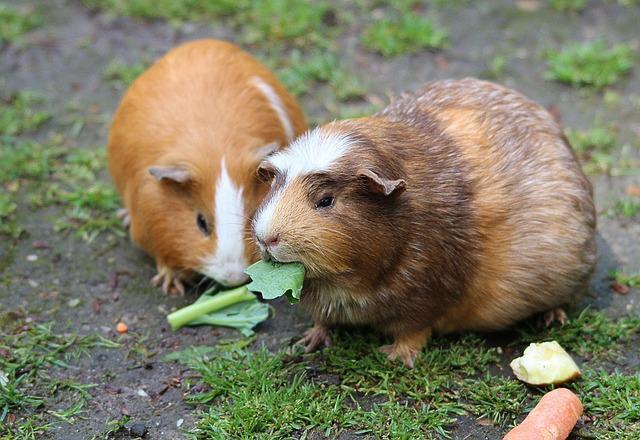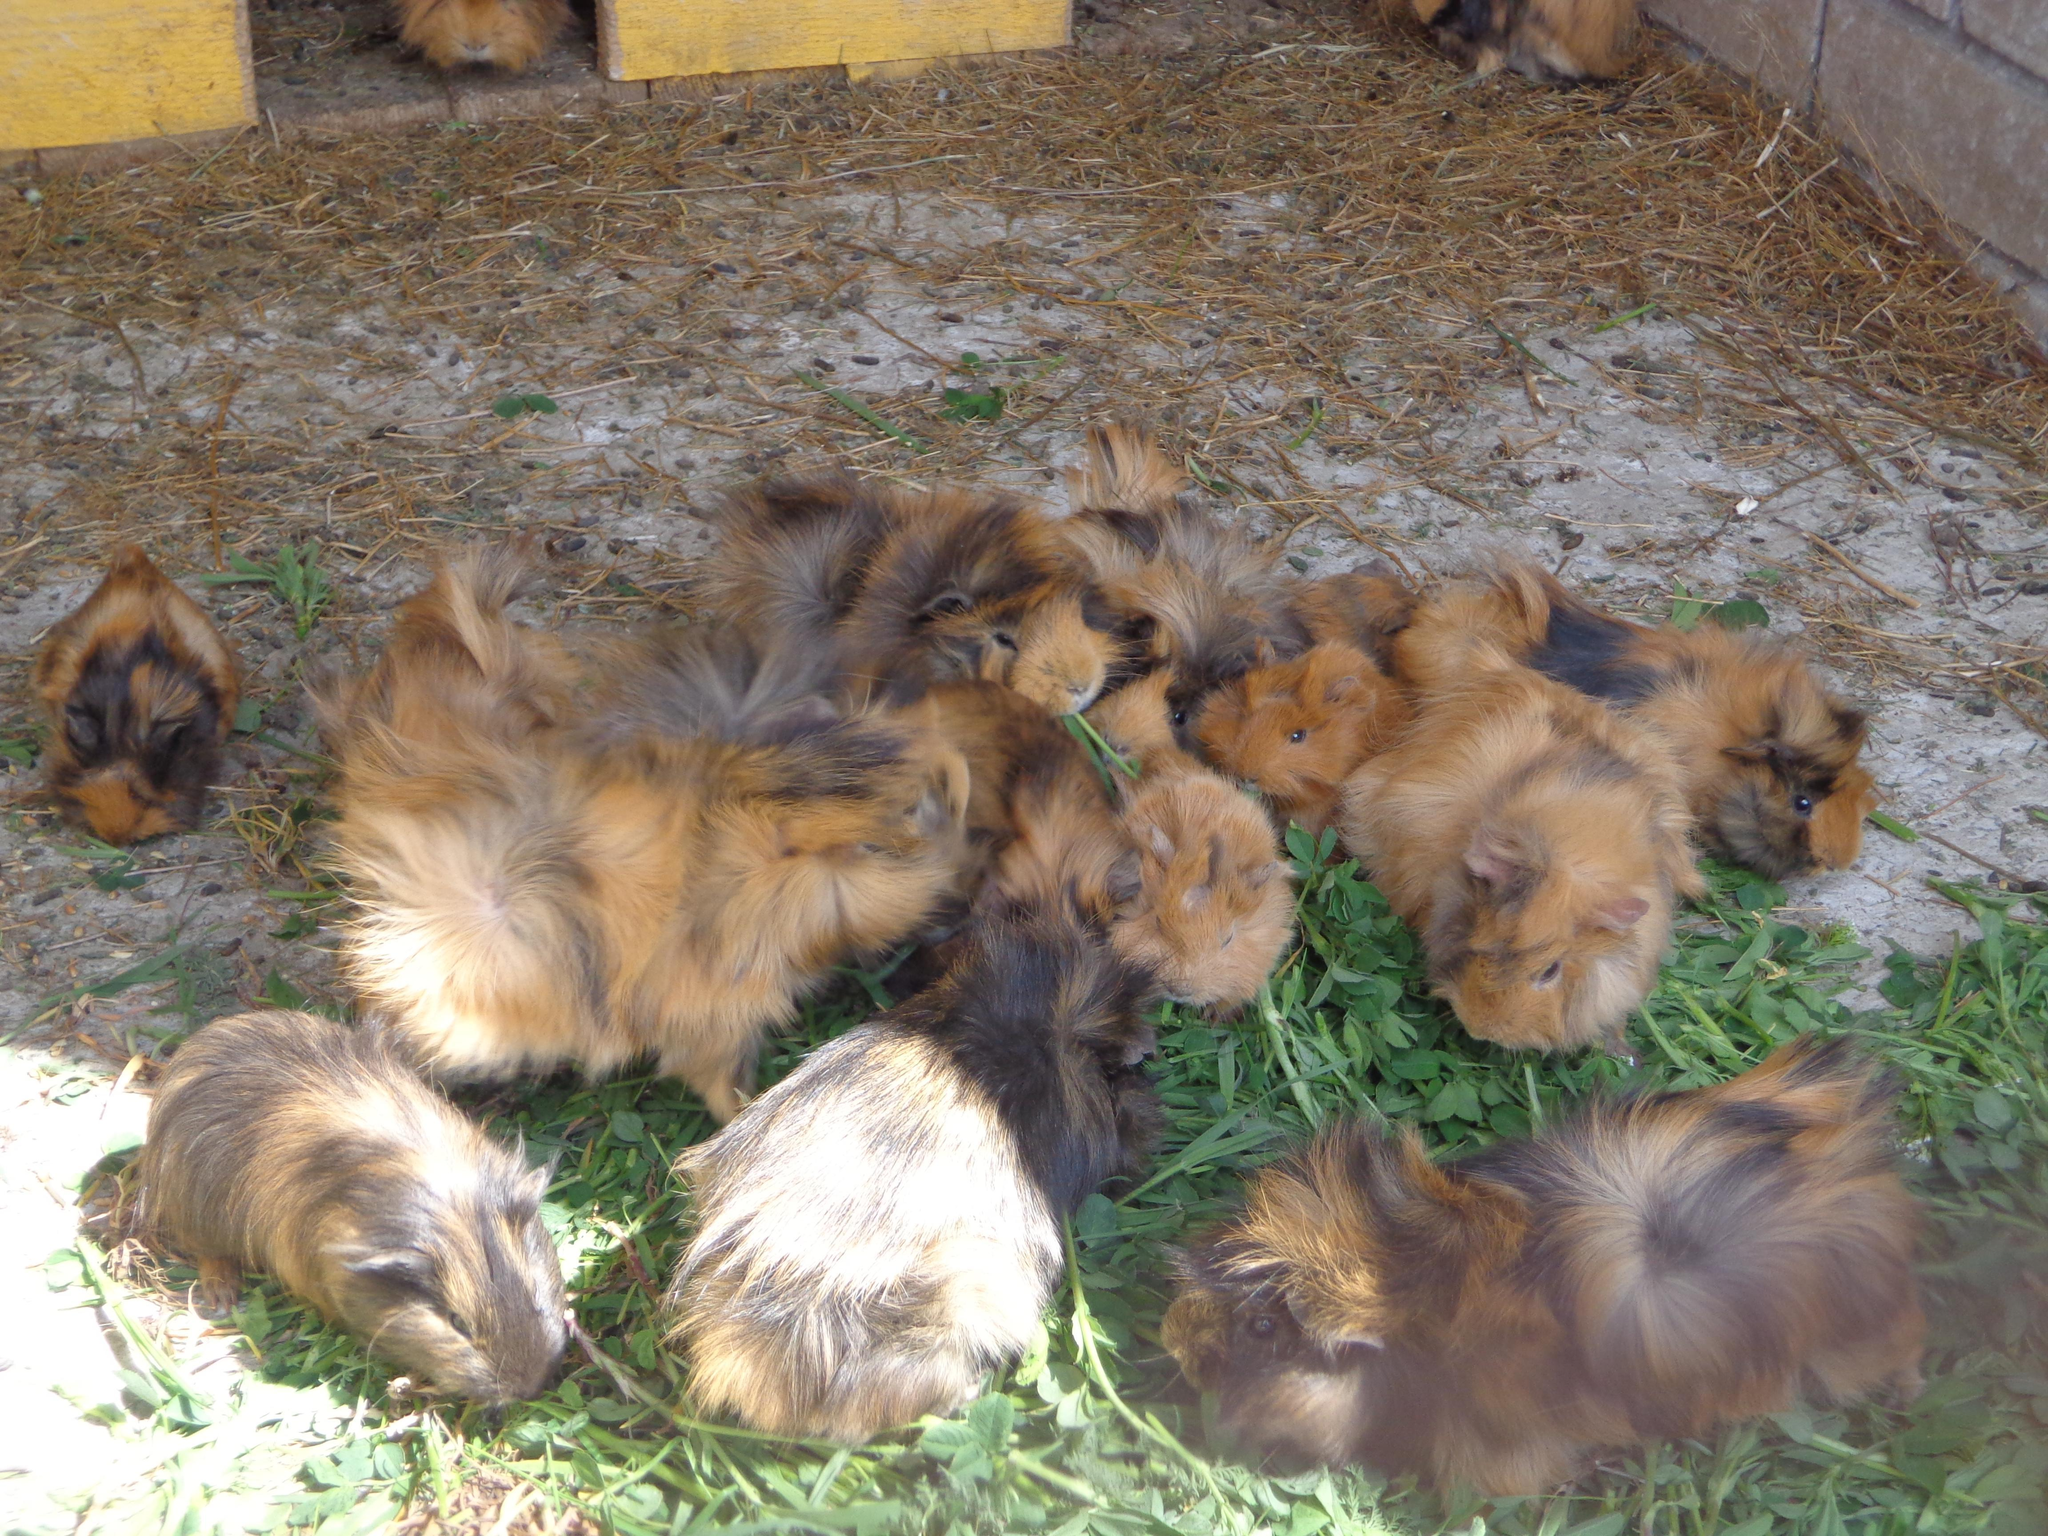The first image is the image on the left, the second image is the image on the right. For the images displayed, is the sentence "There are fewer than four guinea pigs in both images." factually correct? Answer yes or no. No. 